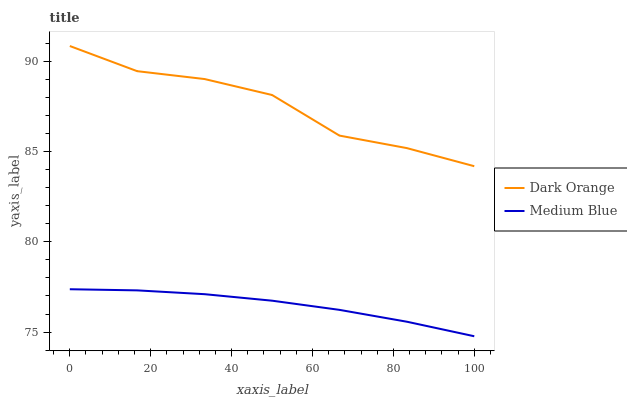Does Medium Blue have the maximum area under the curve?
Answer yes or no. No. Is Medium Blue the roughest?
Answer yes or no. No. Does Medium Blue have the highest value?
Answer yes or no. No. Is Medium Blue less than Dark Orange?
Answer yes or no. Yes. Is Dark Orange greater than Medium Blue?
Answer yes or no. Yes. Does Medium Blue intersect Dark Orange?
Answer yes or no. No. 